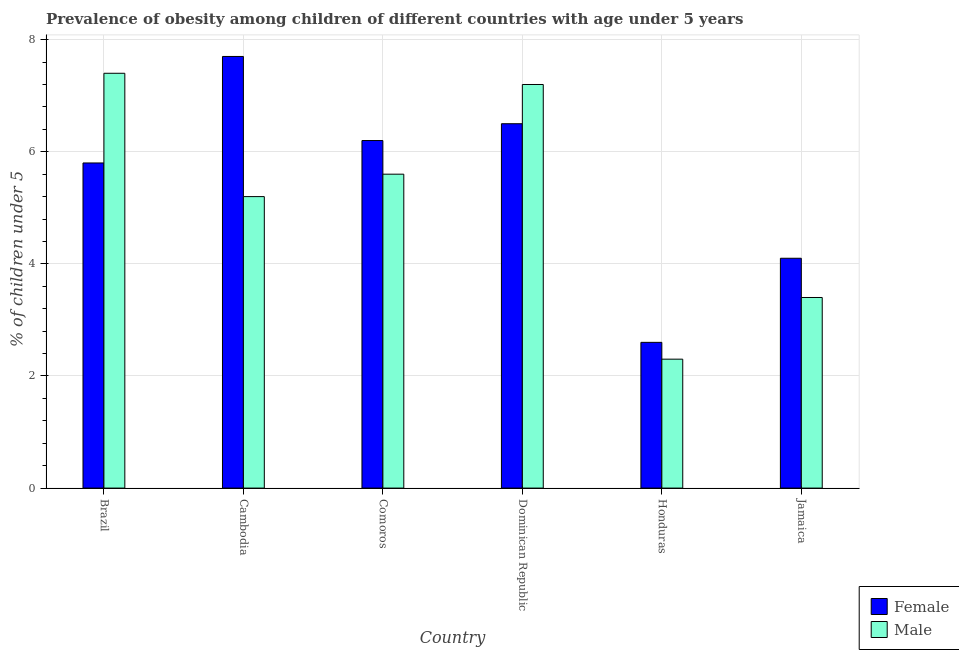Are the number of bars per tick equal to the number of legend labels?
Ensure brevity in your answer.  Yes. Are the number of bars on each tick of the X-axis equal?
Ensure brevity in your answer.  Yes. How many bars are there on the 2nd tick from the right?
Provide a short and direct response. 2. What is the label of the 5th group of bars from the left?
Provide a short and direct response. Honduras. What is the percentage of obese male children in Brazil?
Your answer should be compact. 7.4. Across all countries, what is the maximum percentage of obese female children?
Keep it short and to the point. 7.7. Across all countries, what is the minimum percentage of obese male children?
Keep it short and to the point. 2.3. In which country was the percentage of obese female children maximum?
Your answer should be very brief. Cambodia. In which country was the percentage of obese male children minimum?
Offer a very short reply. Honduras. What is the total percentage of obese female children in the graph?
Provide a succinct answer. 32.9. What is the difference between the percentage of obese male children in Cambodia and that in Jamaica?
Give a very brief answer. 1.8. What is the difference between the percentage of obese female children in Brazil and the percentage of obese male children in Jamaica?
Your answer should be compact. 2.4. What is the average percentage of obese female children per country?
Provide a short and direct response. 5.48. What is the difference between the percentage of obese male children and percentage of obese female children in Jamaica?
Your answer should be very brief. -0.7. What is the ratio of the percentage of obese female children in Honduras to that in Jamaica?
Provide a succinct answer. 0.63. What is the difference between the highest and the second highest percentage of obese male children?
Give a very brief answer. 0.2. What is the difference between the highest and the lowest percentage of obese male children?
Offer a terse response. 5.1. What does the 2nd bar from the right in Jamaica represents?
Ensure brevity in your answer.  Female. Are all the bars in the graph horizontal?
Offer a terse response. No. How many countries are there in the graph?
Keep it short and to the point. 6. Are the values on the major ticks of Y-axis written in scientific E-notation?
Provide a succinct answer. No. Does the graph contain any zero values?
Keep it short and to the point. No. Does the graph contain grids?
Give a very brief answer. Yes. Where does the legend appear in the graph?
Give a very brief answer. Bottom right. What is the title of the graph?
Make the answer very short. Prevalence of obesity among children of different countries with age under 5 years. What is the label or title of the Y-axis?
Give a very brief answer.  % of children under 5. What is the  % of children under 5 of Female in Brazil?
Your answer should be very brief. 5.8. What is the  % of children under 5 in Male in Brazil?
Your answer should be compact. 7.4. What is the  % of children under 5 in Female in Cambodia?
Offer a terse response. 7.7. What is the  % of children under 5 in Male in Cambodia?
Make the answer very short. 5.2. What is the  % of children under 5 of Female in Comoros?
Ensure brevity in your answer.  6.2. What is the  % of children under 5 of Male in Comoros?
Provide a succinct answer. 5.6. What is the  % of children under 5 in Male in Dominican Republic?
Keep it short and to the point. 7.2. What is the  % of children under 5 of Female in Honduras?
Give a very brief answer. 2.6. What is the  % of children under 5 of Male in Honduras?
Keep it short and to the point. 2.3. What is the  % of children under 5 in Female in Jamaica?
Your answer should be very brief. 4.1. What is the  % of children under 5 in Male in Jamaica?
Make the answer very short. 3.4. Across all countries, what is the maximum  % of children under 5 of Female?
Keep it short and to the point. 7.7. Across all countries, what is the maximum  % of children under 5 of Male?
Offer a very short reply. 7.4. Across all countries, what is the minimum  % of children under 5 in Female?
Offer a terse response. 2.6. Across all countries, what is the minimum  % of children under 5 of Male?
Provide a succinct answer. 2.3. What is the total  % of children under 5 of Female in the graph?
Provide a short and direct response. 32.9. What is the total  % of children under 5 in Male in the graph?
Your answer should be compact. 31.1. What is the difference between the  % of children under 5 of Male in Brazil and that in Cambodia?
Provide a succinct answer. 2.2. What is the difference between the  % of children under 5 of Female in Brazil and that in Comoros?
Offer a very short reply. -0.4. What is the difference between the  % of children under 5 in Male in Brazil and that in Dominican Republic?
Keep it short and to the point. 0.2. What is the difference between the  % of children under 5 in Female in Brazil and that in Honduras?
Provide a succinct answer. 3.2. What is the difference between the  % of children under 5 in Male in Brazil and that in Honduras?
Provide a succinct answer. 5.1. What is the difference between the  % of children under 5 of Male in Brazil and that in Jamaica?
Your answer should be compact. 4. What is the difference between the  % of children under 5 of Male in Cambodia and that in Comoros?
Ensure brevity in your answer.  -0.4. What is the difference between the  % of children under 5 in Male in Cambodia and that in Dominican Republic?
Give a very brief answer. -2. What is the difference between the  % of children under 5 in Female in Cambodia and that in Honduras?
Offer a terse response. 5.1. What is the difference between the  % of children under 5 of Male in Cambodia and that in Honduras?
Offer a terse response. 2.9. What is the difference between the  % of children under 5 in Female in Cambodia and that in Jamaica?
Make the answer very short. 3.6. What is the difference between the  % of children under 5 of Male in Cambodia and that in Jamaica?
Your answer should be compact. 1.8. What is the difference between the  % of children under 5 in Female in Comoros and that in Dominican Republic?
Ensure brevity in your answer.  -0.3. What is the difference between the  % of children under 5 of Female in Comoros and that in Honduras?
Your answer should be compact. 3.6. What is the difference between the  % of children under 5 of Male in Comoros and that in Honduras?
Your answer should be very brief. 3.3. What is the difference between the  % of children under 5 in Female in Comoros and that in Jamaica?
Offer a very short reply. 2.1. What is the difference between the  % of children under 5 in Female in Dominican Republic and that in Jamaica?
Provide a short and direct response. 2.4. What is the difference between the  % of children under 5 in Male in Dominican Republic and that in Jamaica?
Offer a very short reply. 3.8. What is the difference between the  % of children under 5 in Female in Brazil and the  % of children under 5 in Male in Cambodia?
Your response must be concise. 0.6. What is the difference between the  % of children under 5 of Female in Brazil and the  % of children under 5 of Male in Dominican Republic?
Your answer should be very brief. -1.4. What is the difference between the  % of children under 5 in Female in Brazil and the  % of children under 5 in Male in Jamaica?
Your answer should be compact. 2.4. What is the difference between the  % of children under 5 of Female in Cambodia and the  % of children under 5 of Male in Comoros?
Your answer should be very brief. 2.1. What is the difference between the  % of children under 5 of Female in Comoros and the  % of children under 5 of Male in Honduras?
Your answer should be very brief. 3.9. What is the difference between the  % of children under 5 of Female in Comoros and the  % of children under 5 of Male in Jamaica?
Give a very brief answer. 2.8. What is the difference between the  % of children under 5 in Female in Dominican Republic and the  % of children under 5 in Male in Honduras?
Make the answer very short. 4.2. What is the difference between the  % of children under 5 of Female in Dominican Republic and the  % of children under 5 of Male in Jamaica?
Provide a succinct answer. 3.1. What is the difference between the  % of children under 5 of Female in Honduras and the  % of children under 5 of Male in Jamaica?
Your answer should be compact. -0.8. What is the average  % of children under 5 in Female per country?
Provide a succinct answer. 5.48. What is the average  % of children under 5 of Male per country?
Offer a terse response. 5.18. What is the difference between the  % of children under 5 in Female and  % of children under 5 in Male in Dominican Republic?
Give a very brief answer. -0.7. What is the difference between the  % of children under 5 of Female and  % of children under 5 of Male in Honduras?
Your response must be concise. 0.3. What is the ratio of the  % of children under 5 of Female in Brazil to that in Cambodia?
Ensure brevity in your answer.  0.75. What is the ratio of the  % of children under 5 in Male in Brazil to that in Cambodia?
Make the answer very short. 1.42. What is the ratio of the  % of children under 5 in Female in Brazil to that in Comoros?
Provide a succinct answer. 0.94. What is the ratio of the  % of children under 5 in Male in Brazil to that in Comoros?
Your response must be concise. 1.32. What is the ratio of the  % of children under 5 in Female in Brazil to that in Dominican Republic?
Make the answer very short. 0.89. What is the ratio of the  % of children under 5 of Male in Brazil to that in Dominican Republic?
Give a very brief answer. 1.03. What is the ratio of the  % of children under 5 in Female in Brazil to that in Honduras?
Give a very brief answer. 2.23. What is the ratio of the  % of children under 5 in Male in Brazil to that in Honduras?
Your answer should be compact. 3.22. What is the ratio of the  % of children under 5 in Female in Brazil to that in Jamaica?
Give a very brief answer. 1.41. What is the ratio of the  % of children under 5 in Male in Brazil to that in Jamaica?
Ensure brevity in your answer.  2.18. What is the ratio of the  % of children under 5 in Female in Cambodia to that in Comoros?
Keep it short and to the point. 1.24. What is the ratio of the  % of children under 5 of Female in Cambodia to that in Dominican Republic?
Make the answer very short. 1.18. What is the ratio of the  % of children under 5 in Male in Cambodia to that in Dominican Republic?
Your answer should be compact. 0.72. What is the ratio of the  % of children under 5 of Female in Cambodia to that in Honduras?
Offer a terse response. 2.96. What is the ratio of the  % of children under 5 in Male in Cambodia to that in Honduras?
Your answer should be compact. 2.26. What is the ratio of the  % of children under 5 in Female in Cambodia to that in Jamaica?
Provide a succinct answer. 1.88. What is the ratio of the  % of children under 5 in Male in Cambodia to that in Jamaica?
Your answer should be compact. 1.53. What is the ratio of the  % of children under 5 of Female in Comoros to that in Dominican Republic?
Ensure brevity in your answer.  0.95. What is the ratio of the  % of children under 5 of Female in Comoros to that in Honduras?
Give a very brief answer. 2.38. What is the ratio of the  % of children under 5 in Male in Comoros to that in Honduras?
Keep it short and to the point. 2.43. What is the ratio of the  % of children under 5 in Female in Comoros to that in Jamaica?
Give a very brief answer. 1.51. What is the ratio of the  % of children under 5 in Male in Comoros to that in Jamaica?
Ensure brevity in your answer.  1.65. What is the ratio of the  % of children under 5 in Female in Dominican Republic to that in Honduras?
Offer a terse response. 2.5. What is the ratio of the  % of children under 5 of Male in Dominican Republic to that in Honduras?
Your answer should be compact. 3.13. What is the ratio of the  % of children under 5 of Female in Dominican Republic to that in Jamaica?
Provide a succinct answer. 1.59. What is the ratio of the  % of children under 5 of Male in Dominican Republic to that in Jamaica?
Offer a terse response. 2.12. What is the ratio of the  % of children under 5 in Female in Honduras to that in Jamaica?
Make the answer very short. 0.63. What is the ratio of the  % of children under 5 in Male in Honduras to that in Jamaica?
Keep it short and to the point. 0.68. What is the difference between the highest and the second highest  % of children under 5 in Female?
Give a very brief answer. 1.2. 